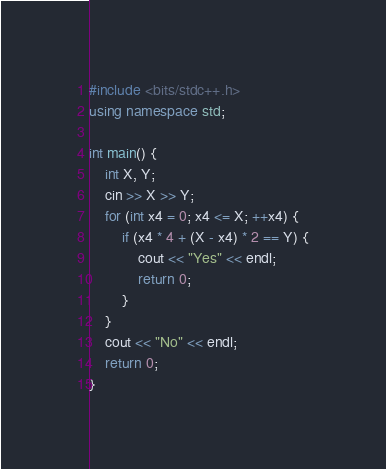<code> <loc_0><loc_0><loc_500><loc_500><_C++_>#include <bits/stdc++.h>
using namespace std;

int main() {
    int X, Y;
    cin >> X >> Y;
    for (int x4 = 0; x4 <= X; ++x4) {
        if (x4 * 4 + (X - x4) * 2 == Y) {
            cout << "Yes" << endl;
            return 0;
        }
    }
    cout << "No" << endl;
    return 0;
}</code> 